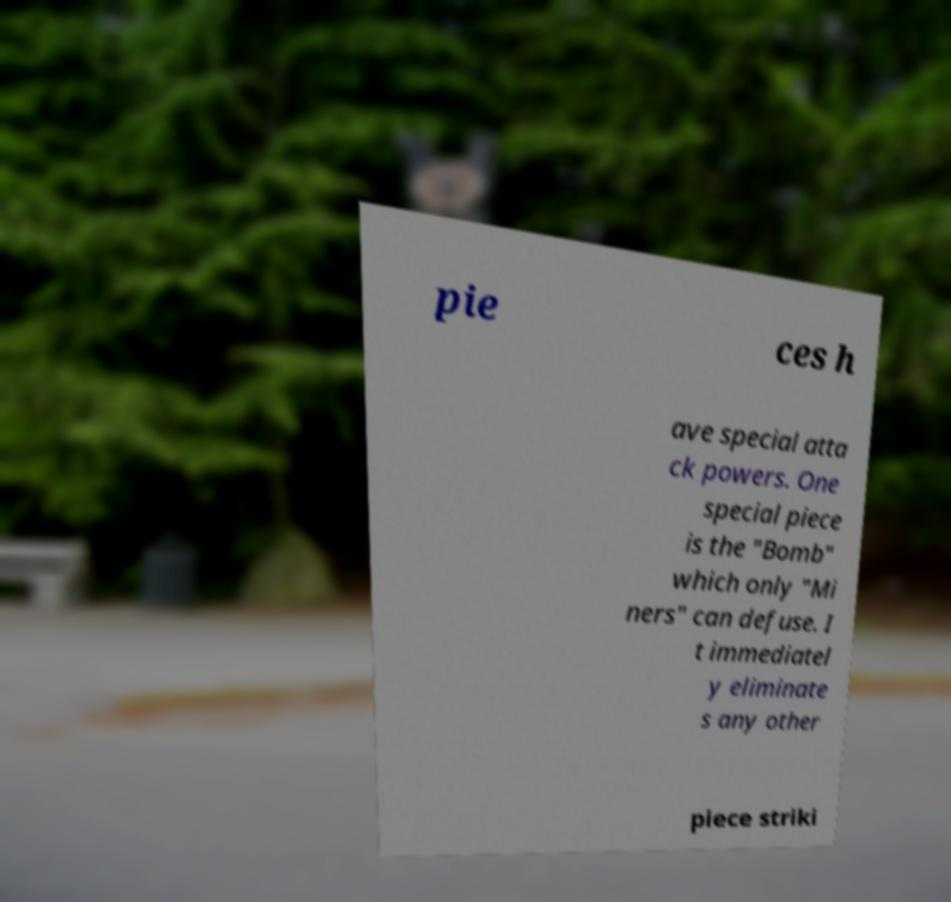There's text embedded in this image that I need extracted. Can you transcribe it verbatim? pie ces h ave special atta ck powers. One special piece is the "Bomb" which only "Mi ners" can defuse. I t immediatel y eliminate s any other piece striki 